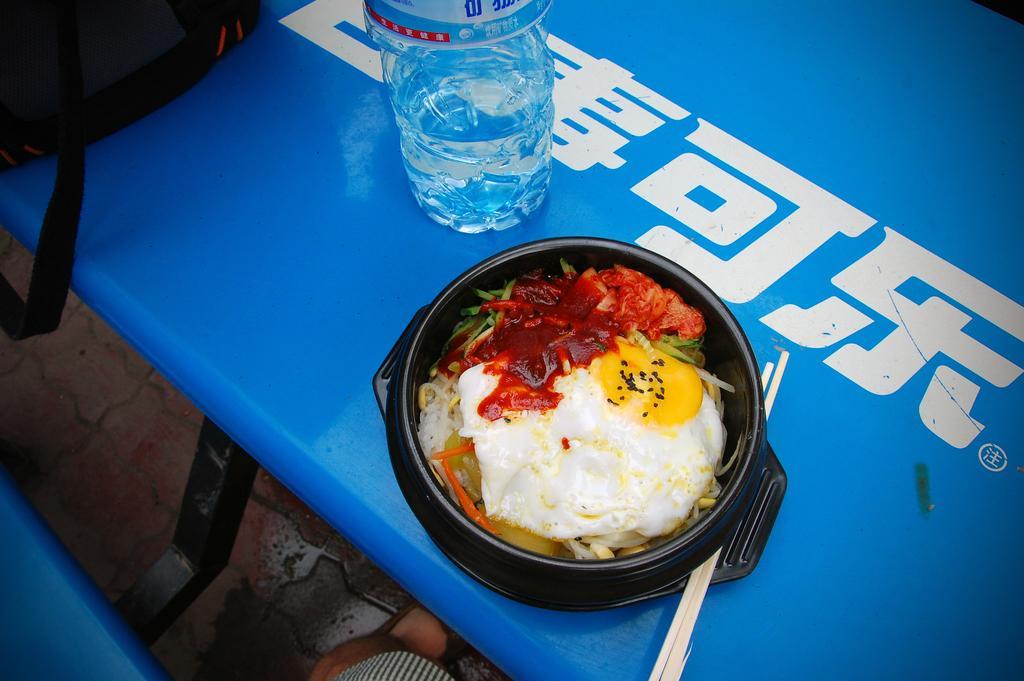Please provide a concise description of this image. In this Image I see a bottle, a bowl full of food and chopsticks and a bag on the table. 